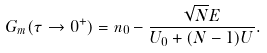Convert formula to latex. <formula><loc_0><loc_0><loc_500><loc_500>G _ { m } ( \tau \rightarrow 0 ^ { + } ) = n _ { 0 } - \frac { \sqrt { N } E } { U _ { 0 } + ( N - 1 ) U } .</formula> 